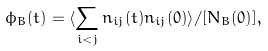<formula> <loc_0><loc_0><loc_500><loc_500>\phi _ { B } ( t ) = \langle \sum _ { i < j } n _ { i j } ( t ) n _ { i j } ( 0 ) \rangle / [ N _ { B } ( 0 ) ] ,</formula> 